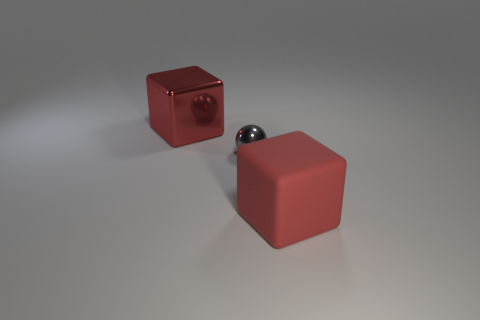Add 3 big purple blocks. How many objects exist? 6 Subtract all blocks. How many objects are left? 1 Add 2 tiny gray metallic spheres. How many tiny gray metallic spheres are left? 3 Add 1 big cyan balls. How many big cyan balls exist? 1 Subtract 0 cyan spheres. How many objects are left? 3 Subtract all small objects. Subtract all small gray metallic things. How many objects are left? 1 